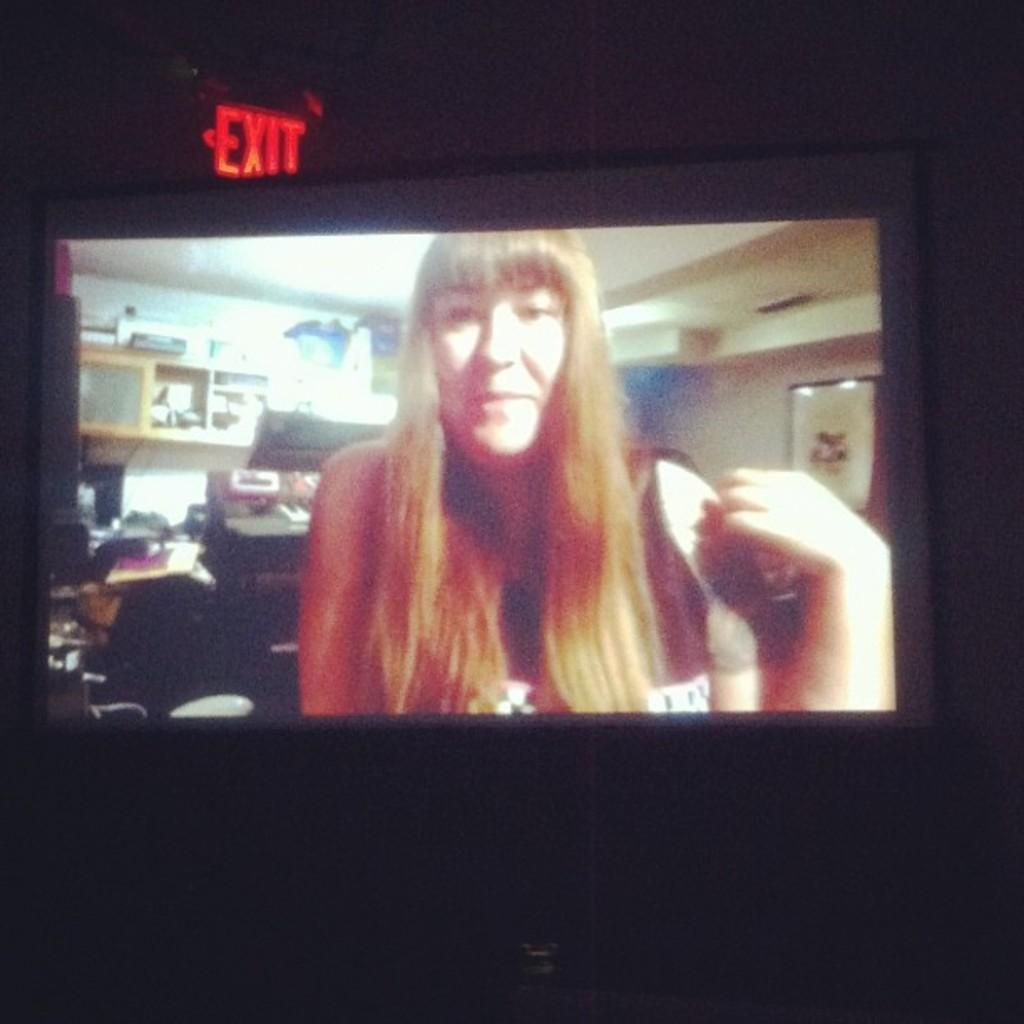<image>
Provide a brief description of the given image. A red haired woman on a tv screen under an exit sign. 